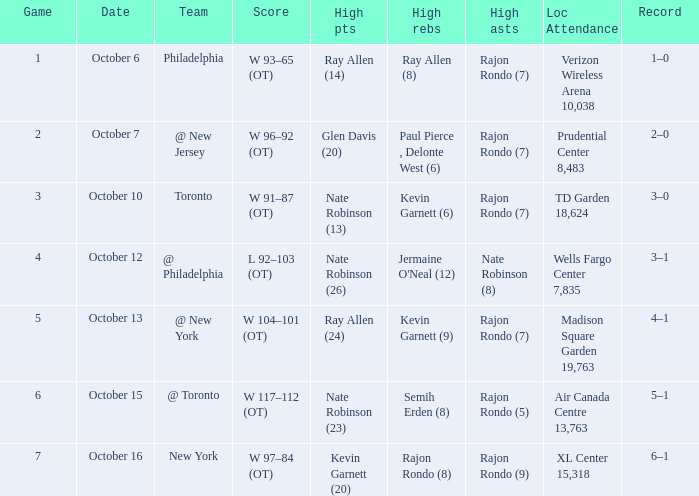Can you give me this table as a dict? {'header': ['Game', 'Date', 'Team', 'Score', 'High pts', 'High rebs', 'High asts', 'Loc Attendance', 'Record'], 'rows': [['1', 'October 6', 'Philadelphia', 'W 93–65 (OT)', 'Ray Allen (14)', 'Ray Allen (8)', 'Rajon Rondo (7)', 'Verizon Wireless Arena 10,038', '1–0'], ['2', 'October 7', '@ New Jersey', 'W 96–92 (OT)', 'Glen Davis (20)', 'Paul Pierce , Delonte West (6)', 'Rajon Rondo (7)', 'Prudential Center 8,483', '2–0'], ['3', 'October 10', 'Toronto', 'W 91–87 (OT)', 'Nate Robinson (13)', 'Kevin Garnett (6)', 'Rajon Rondo (7)', 'TD Garden 18,624', '3–0'], ['4', 'October 12', '@ Philadelphia', 'L 92–103 (OT)', 'Nate Robinson (26)', "Jermaine O'Neal (12)", 'Nate Robinson (8)', 'Wells Fargo Center 7,835', '3–1'], ['5', 'October 13', '@ New York', 'W 104–101 (OT)', 'Ray Allen (24)', 'Kevin Garnett (9)', 'Rajon Rondo (7)', 'Madison Square Garden 19,763', '4–1'], ['6', 'October 15', '@ Toronto', 'W 117–112 (OT)', 'Nate Robinson (23)', 'Semih Erden (8)', 'Rajon Rondo (5)', 'Air Canada Centre 13,763', '5–1'], ['7', 'October 16', 'New York', 'W 97–84 (OT)', 'Kevin Garnett (20)', 'Rajon Rondo (8)', 'Rajon Rondo (9)', 'XL Center 15,318', '6–1']]} Who had the most rebounds and how many did they have on October 16? Rajon Rondo (8). 